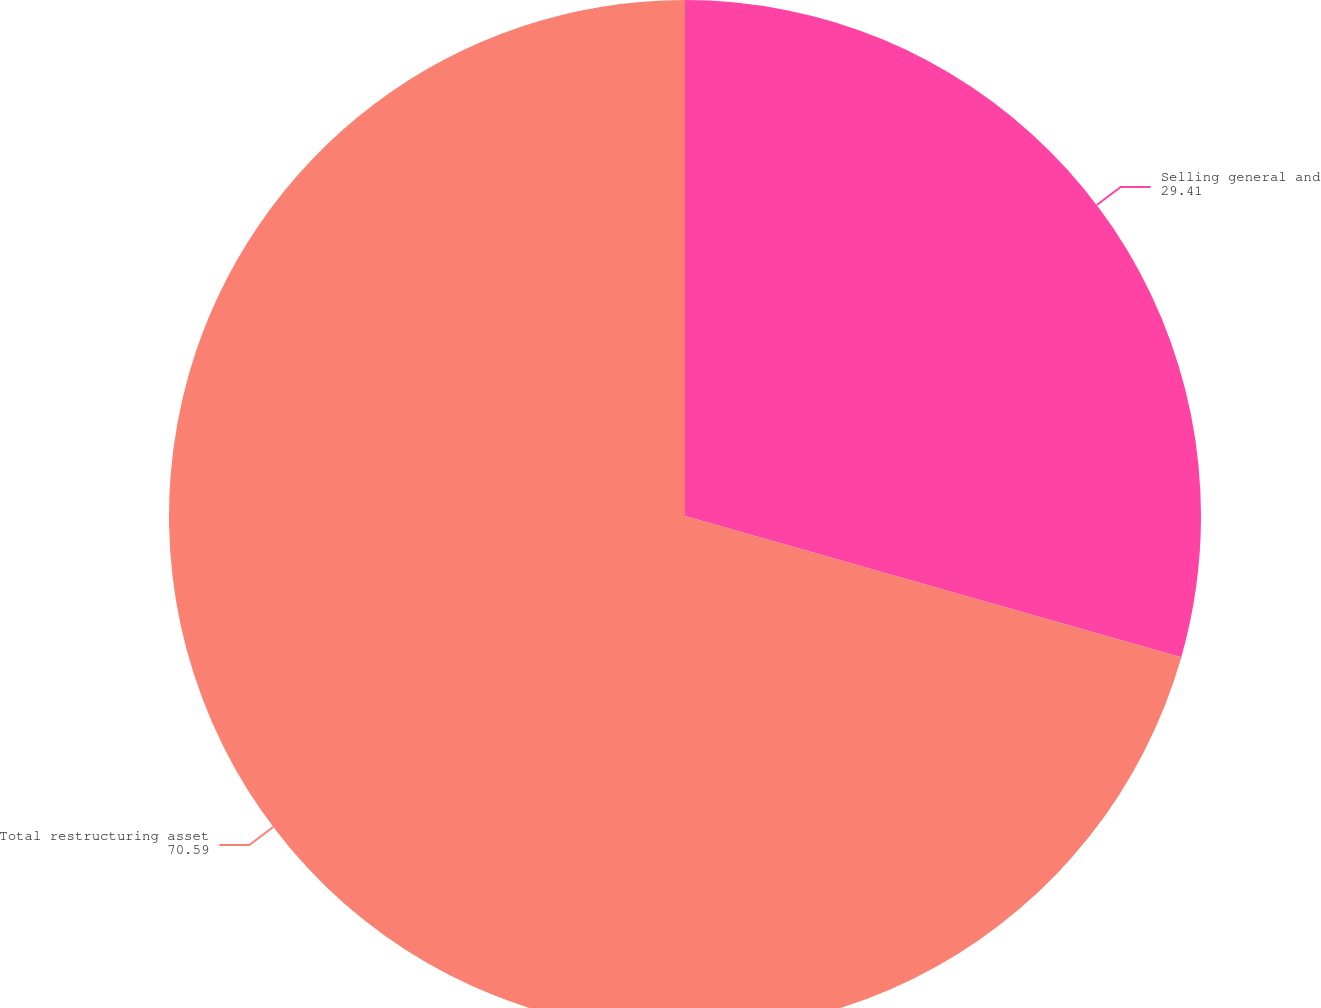<chart> <loc_0><loc_0><loc_500><loc_500><pie_chart><fcel>Selling general and<fcel>Total restructuring asset<nl><fcel>29.41%<fcel>70.59%<nl></chart> 